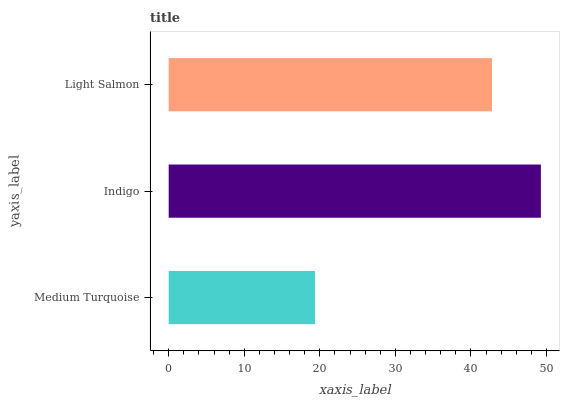Is Medium Turquoise the minimum?
Answer yes or no. Yes. Is Indigo the maximum?
Answer yes or no. Yes. Is Light Salmon the minimum?
Answer yes or no. No. Is Light Salmon the maximum?
Answer yes or no. No. Is Indigo greater than Light Salmon?
Answer yes or no. Yes. Is Light Salmon less than Indigo?
Answer yes or no. Yes. Is Light Salmon greater than Indigo?
Answer yes or no. No. Is Indigo less than Light Salmon?
Answer yes or no. No. Is Light Salmon the high median?
Answer yes or no. Yes. Is Light Salmon the low median?
Answer yes or no. Yes. Is Medium Turquoise the high median?
Answer yes or no. No. Is Medium Turquoise the low median?
Answer yes or no. No. 